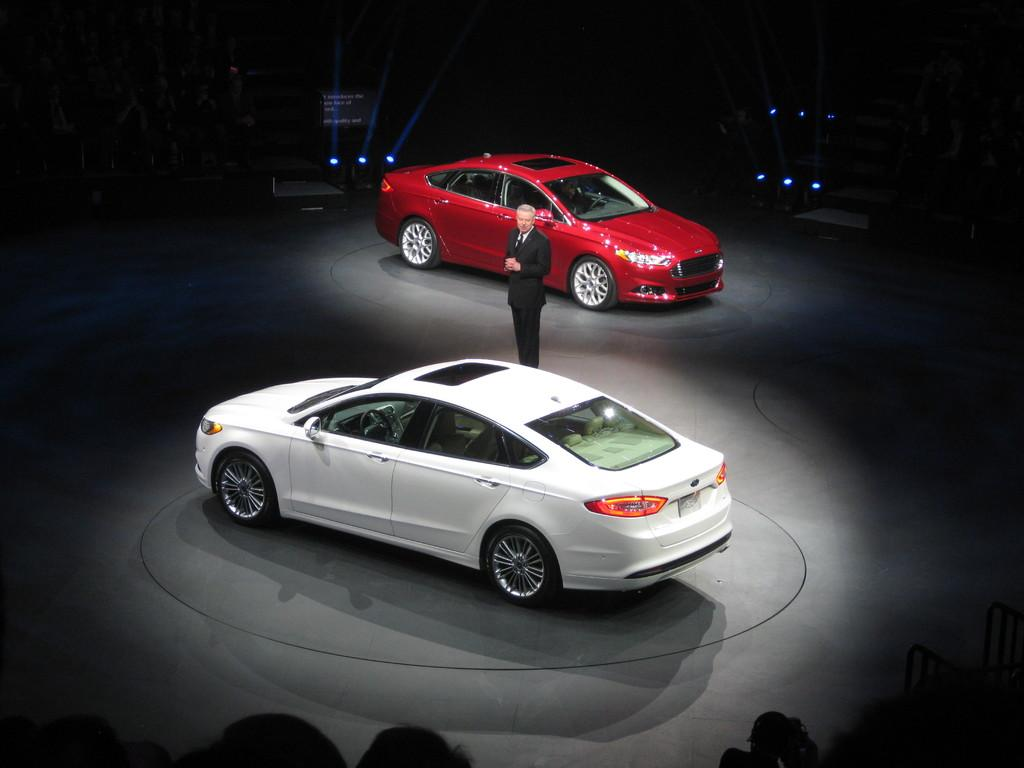How many cars are in the image? There are two cars in the image. What colors are the cars? One car is white, and the other is red. What is the person in the image wearing? The person is wearing a suit. What can be seen at the back of the image? There are lights visible at the back of the image. What type of arithmetic problem is the person solving in the image? There is no indication in the image that the person is solving an arithmetic problem. What language is the person speaking in the image? There is no indication in the image of the person speaking any language. 